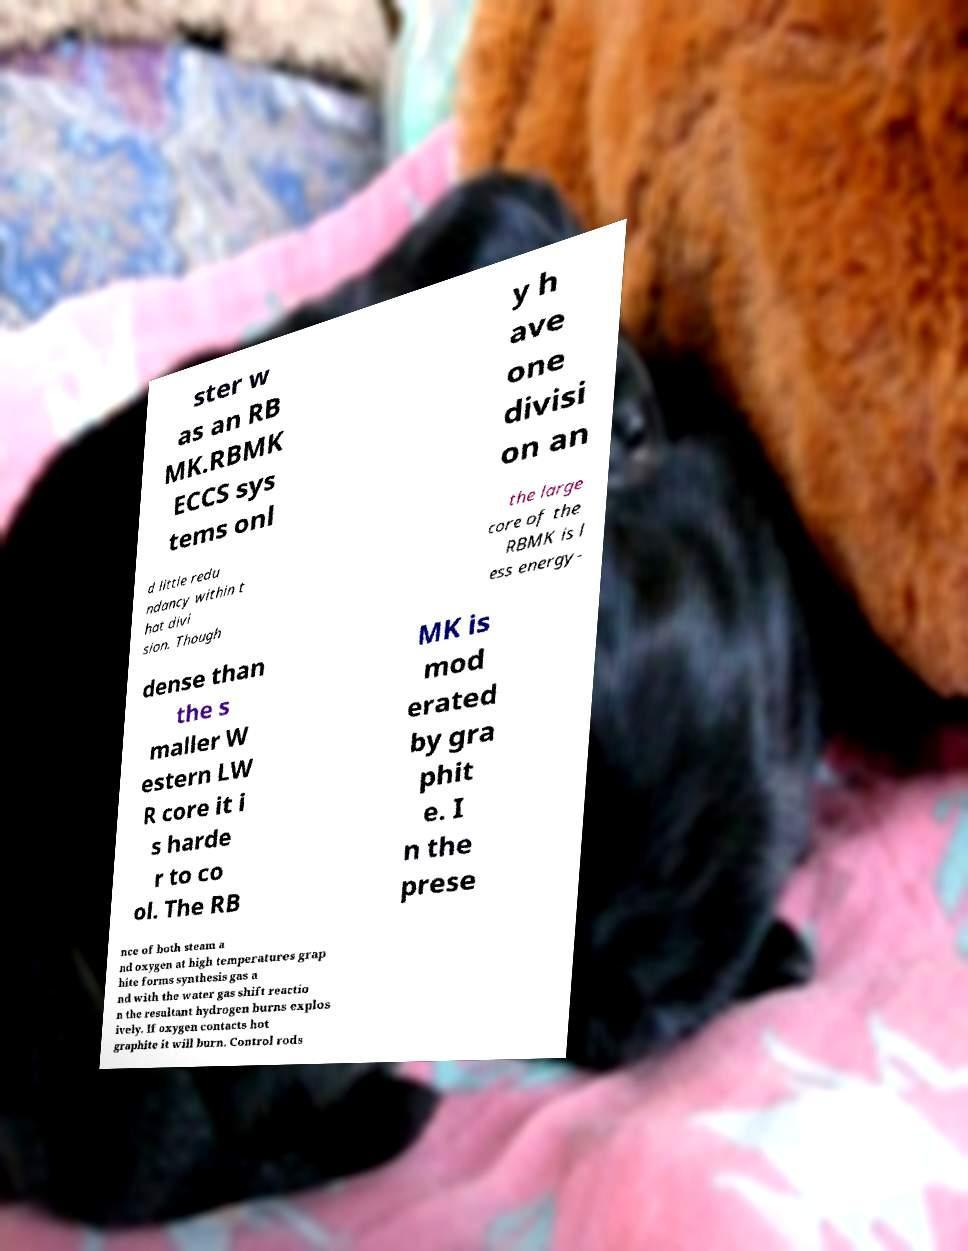Please read and relay the text visible in this image. What does it say? ster w as an RB MK.RBMK ECCS sys tems onl y h ave one divisi on an d little redu ndancy within t hat divi sion. Though the large core of the RBMK is l ess energy- dense than the s maller W estern LW R core it i s harde r to co ol. The RB MK is mod erated by gra phit e. I n the prese nce of both steam a nd oxygen at high temperatures grap hite forms synthesis gas a nd with the water gas shift reactio n the resultant hydrogen burns explos ively. If oxygen contacts hot graphite it will burn. Control rods 